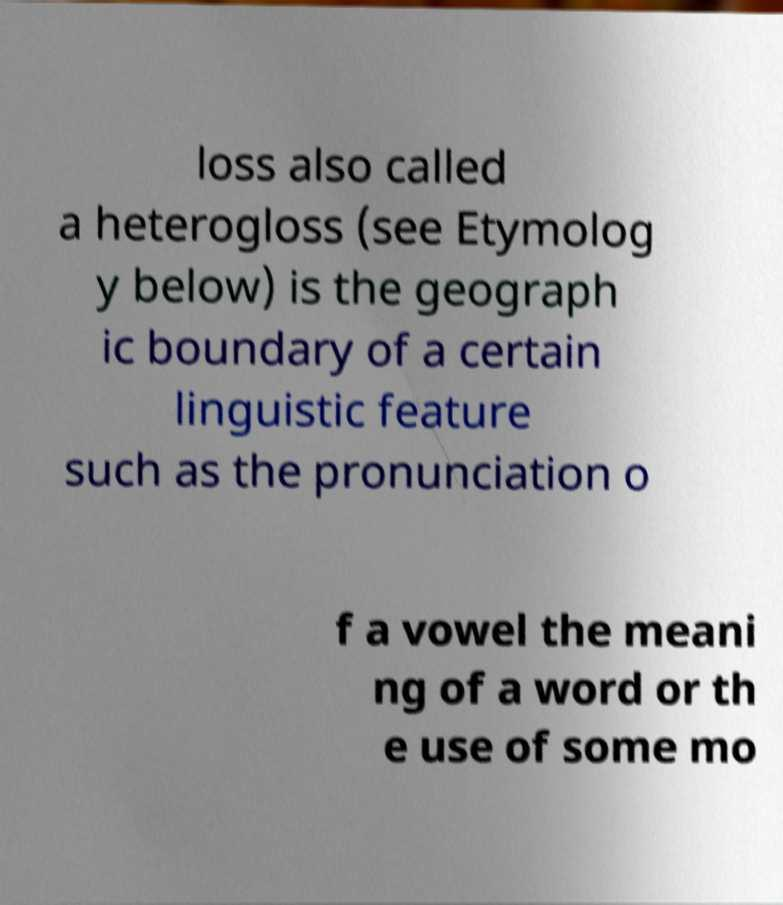I need the written content from this picture converted into text. Can you do that? loss also called a heterogloss (see Etymolog y below) is the geograph ic boundary of a certain linguistic feature such as the pronunciation o f a vowel the meani ng of a word or th e use of some mo 